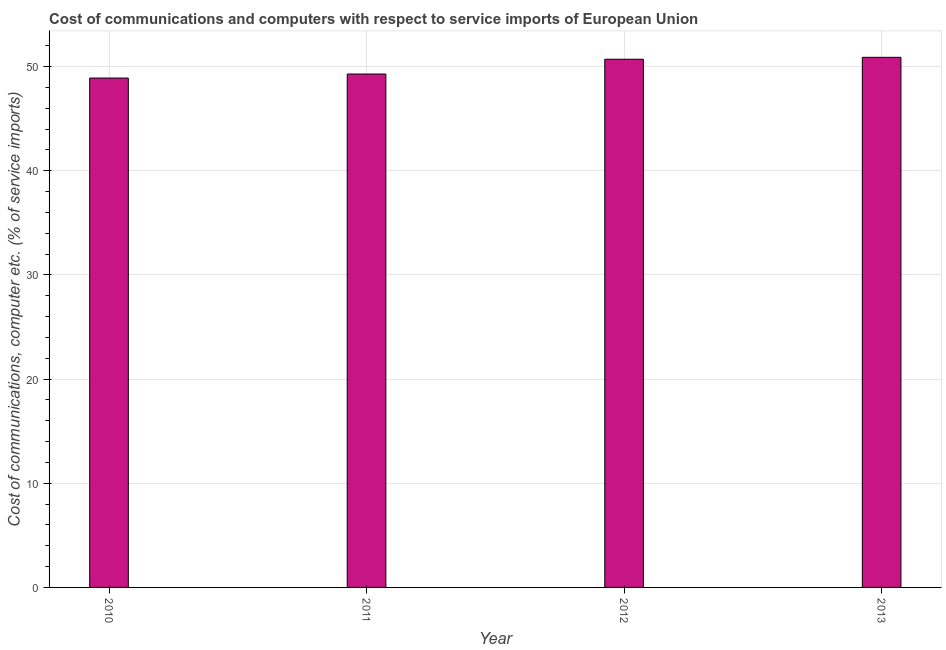Does the graph contain any zero values?
Give a very brief answer. No. What is the title of the graph?
Provide a succinct answer. Cost of communications and computers with respect to service imports of European Union. What is the label or title of the X-axis?
Offer a very short reply. Year. What is the label or title of the Y-axis?
Provide a succinct answer. Cost of communications, computer etc. (% of service imports). What is the cost of communications and computer in 2013?
Your answer should be very brief. 50.89. Across all years, what is the maximum cost of communications and computer?
Offer a very short reply. 50.89. Across all years, what is the minimum cost of communications and computer?
Provide a short and direct response. 48.9. What is the sum of the cost of communications and computer?
Offer a terse response. 199.78. What is the difference between the cost of communications and computer in 2011 and 2013?
Make the answer very short. -1.6. What is the average cost of communications and computer per year?
Keep it short and to the point. 49.95. What is the median cost of communications and computer?
Provide a succinct answer. 50. Is the cost of communications and computer in 2010 less than that in 2011?
Provide a short and direct response. Yes. Is the difference between the cost of communications and computer in 2010 and 2013 greater than the difference between any two years?
Ensure brevity in your answer.  Yes. What is the difference between the highest and the second highest cost of communications and computer?
Make the answer very short. 0.18. What is the difference between the highest and the lowest cost of communications and computer?
Your answer should be compact. 1.99. How many bars are there?
Your answer should be very brief. 4. Are all the bars in the graph horizontal?
Give a very brief answer. No. How many years are there in the graph?
Provide a succinct answer. 4. Are the values on the major ticks of Y-axis written in scientific E-notation?
Offer a terse response. No. What is the Cost of communications, computer etc. (% of service imports) in 2010?
Provide a succinct answer. 48.9. What is the Cost of communications, computer etc. (% of service imports) of 2011?
Offer a very short reply. 49.29. What is the Cost of communications, computer etc. (% of service imports) in 2012?
Ensure brevity in your answer.  50.71. What is the Cost of communications, computer etc. (% of service imports) in 2013?
Your response must be concise. 50.89. What is the difference between the Cost of communications, computer etc. (% of service imports) in 2010 and 2011?
Keep it short and to the point. -0.39. What is the difference between the Cost of communications, computer etc. (% of service imports) in 2010 and 2012?
Your answer should be very brief. -1.81. What is the difference between the Cost of communications, computer etc. (% of service imports) in 2010 and 2013?
Make the answer very short. -1.99. What is the difference between the Cost of communications, computer etc. (% of service imports) in 2011 and 2012?
Provide a short and direct response. -1.42. What is the difference between the Cost of communications, computer etc. (% of service imports) in 2011 and 2013?
Your answer should be very brief. -1.6. What is the difference between the Cost of communications, computer etc. (% of service imports) in 2012 and 2013?
Provide a short and direct response. -0.18. What is the ratio of the Cost of communications, computer etc. (% of service imports) in 2010 to that in 2013?
Your answer should be compact. 0.96. What is the ratio of the Cost of communications, computer etc. (% of service imports) in 2011 to that in 2013?
Make the answer very short. 0.97. What is the ratio of the Cost of communications, computer etc. (% of service imports) in 2012 to that in 2013?
Provide a succinct answer. 1. 